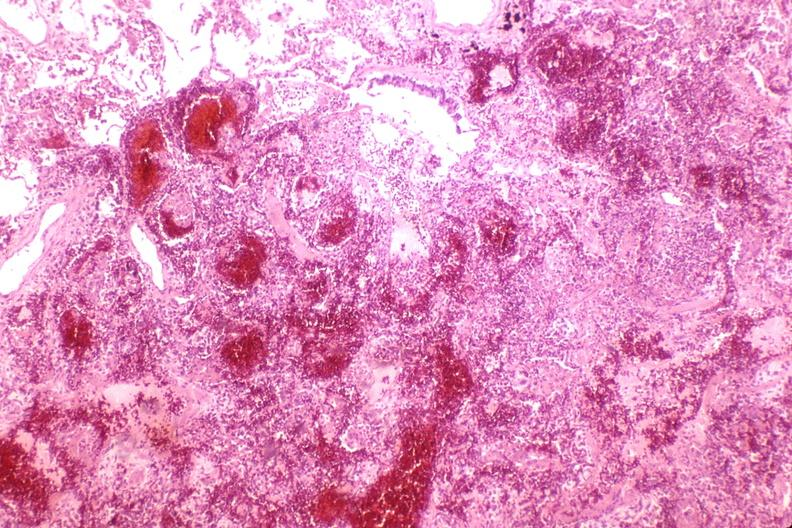where is this?
Answer the question using a single word or phrase. Lung 